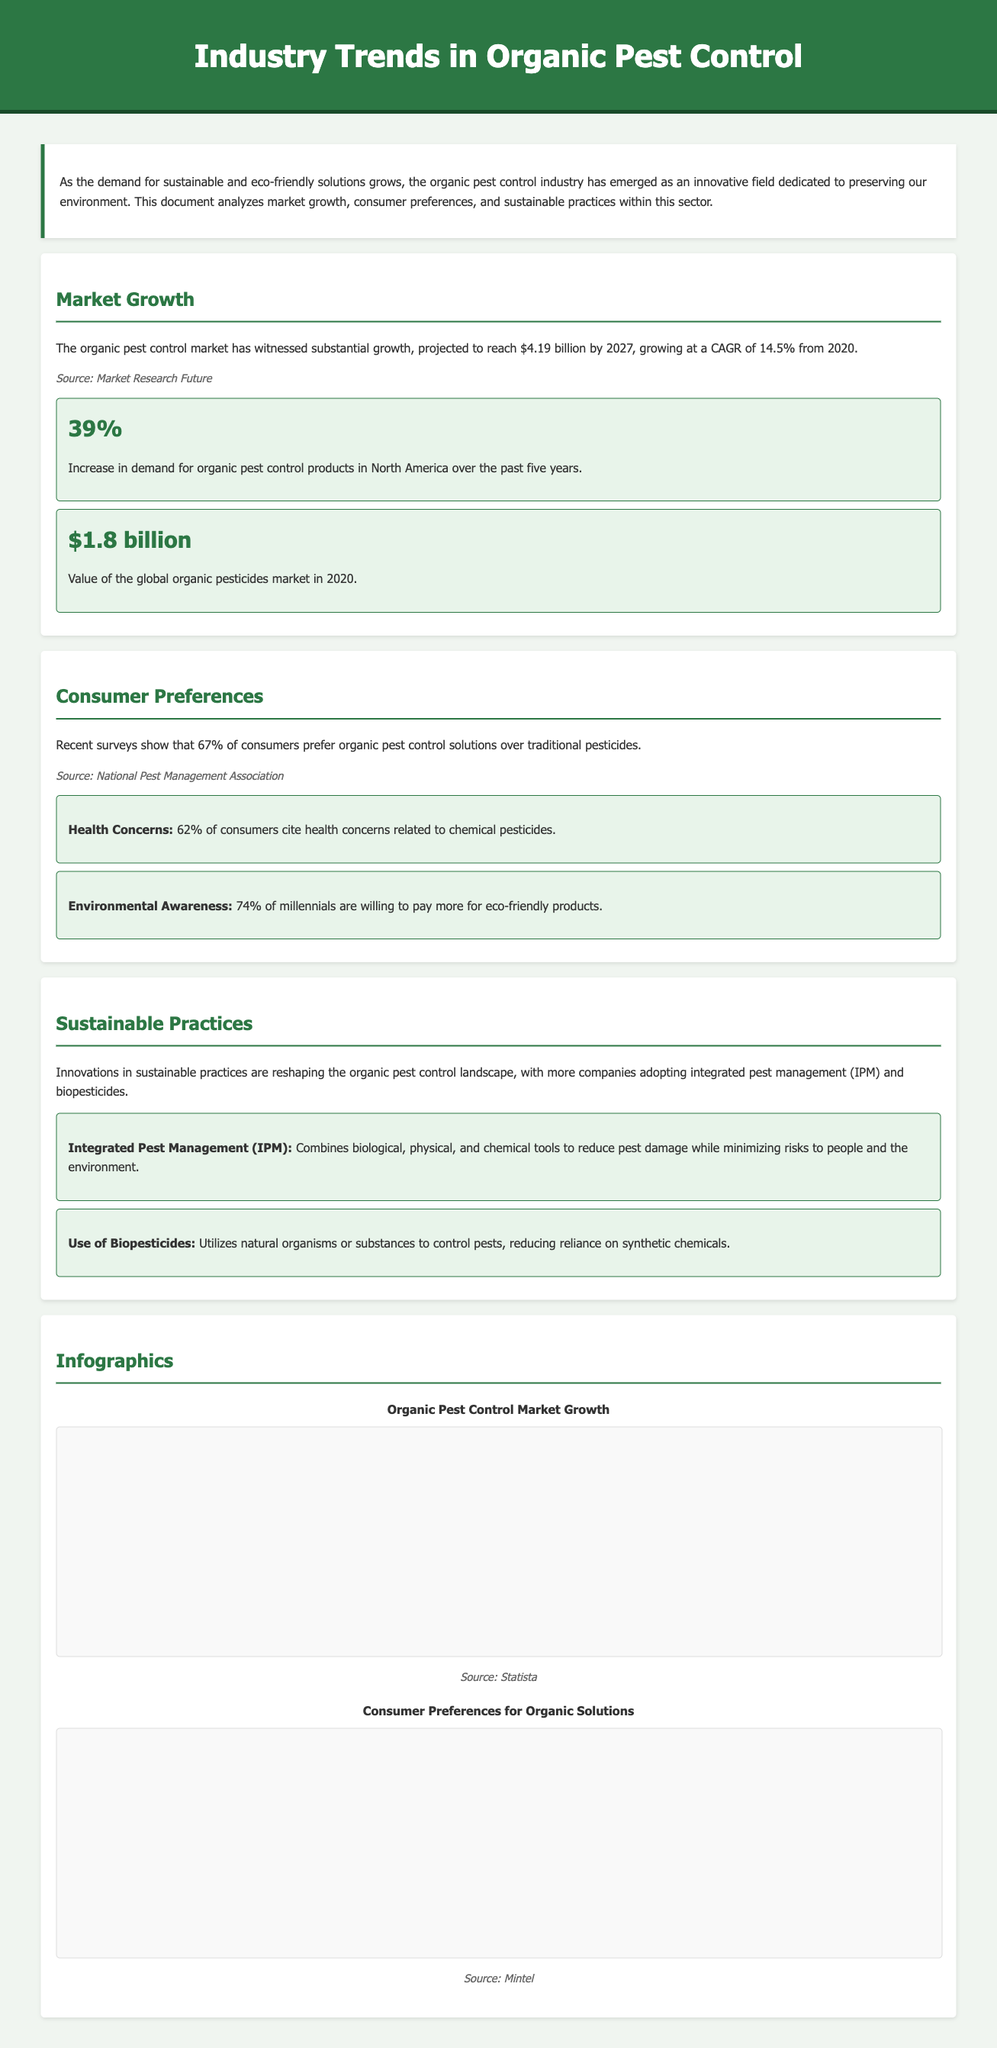What is the projected market value of organic pest control by 2027? The document states that the organic pest control market is projected to reach $4.19 billion by 2027.
Answer: $4.19 billion What percentage of consumers prefer organic pest control solutions? According to recent surveys, 67% of consumers prefer organic pest control solutions over traditional pesticides.
Answer: 67% What is the CAGR of the organic pest control market from 2020? The document highlights that the organic pest control market is growing at a CAGR of 14.5% from 2020.
Answer: 14.5% What is the value of the global organic pesticides market in 2020? The document mentions that the value of the global organic pesticides market in 2020 was $1.8 billion.
Answer: $1.8 billion What percentage of millennials are willing to pay more for eco-friendly products? The document states that 74% of millennials are willing to pay more for eco-friendly products.
Answer: 74% What is Integrated Pest Management (IPM)? Integrated Pest Management (IPM) is mentioned as a practice that combines biological, physical, and chemical tools to manage pest damage while minimizing risks.
Answer: Combination of biological, physical, and chemical tools How many years of demand growth for organic pest control products is indicated for North America? The document indicates a 39% increase in demand for organic pest control products in North America over the past five years.
Answer: Five years What does the green color in the pie chart represent? In the pie chart, the green color represents the percentage of consumers who prefer organic pest control.
Answer: Prefer Organic What type of chart illustrates organic pest control market growth? The bar chart illustrates the organic pest control market growth throughout various years.
Answer: Bar Chart 